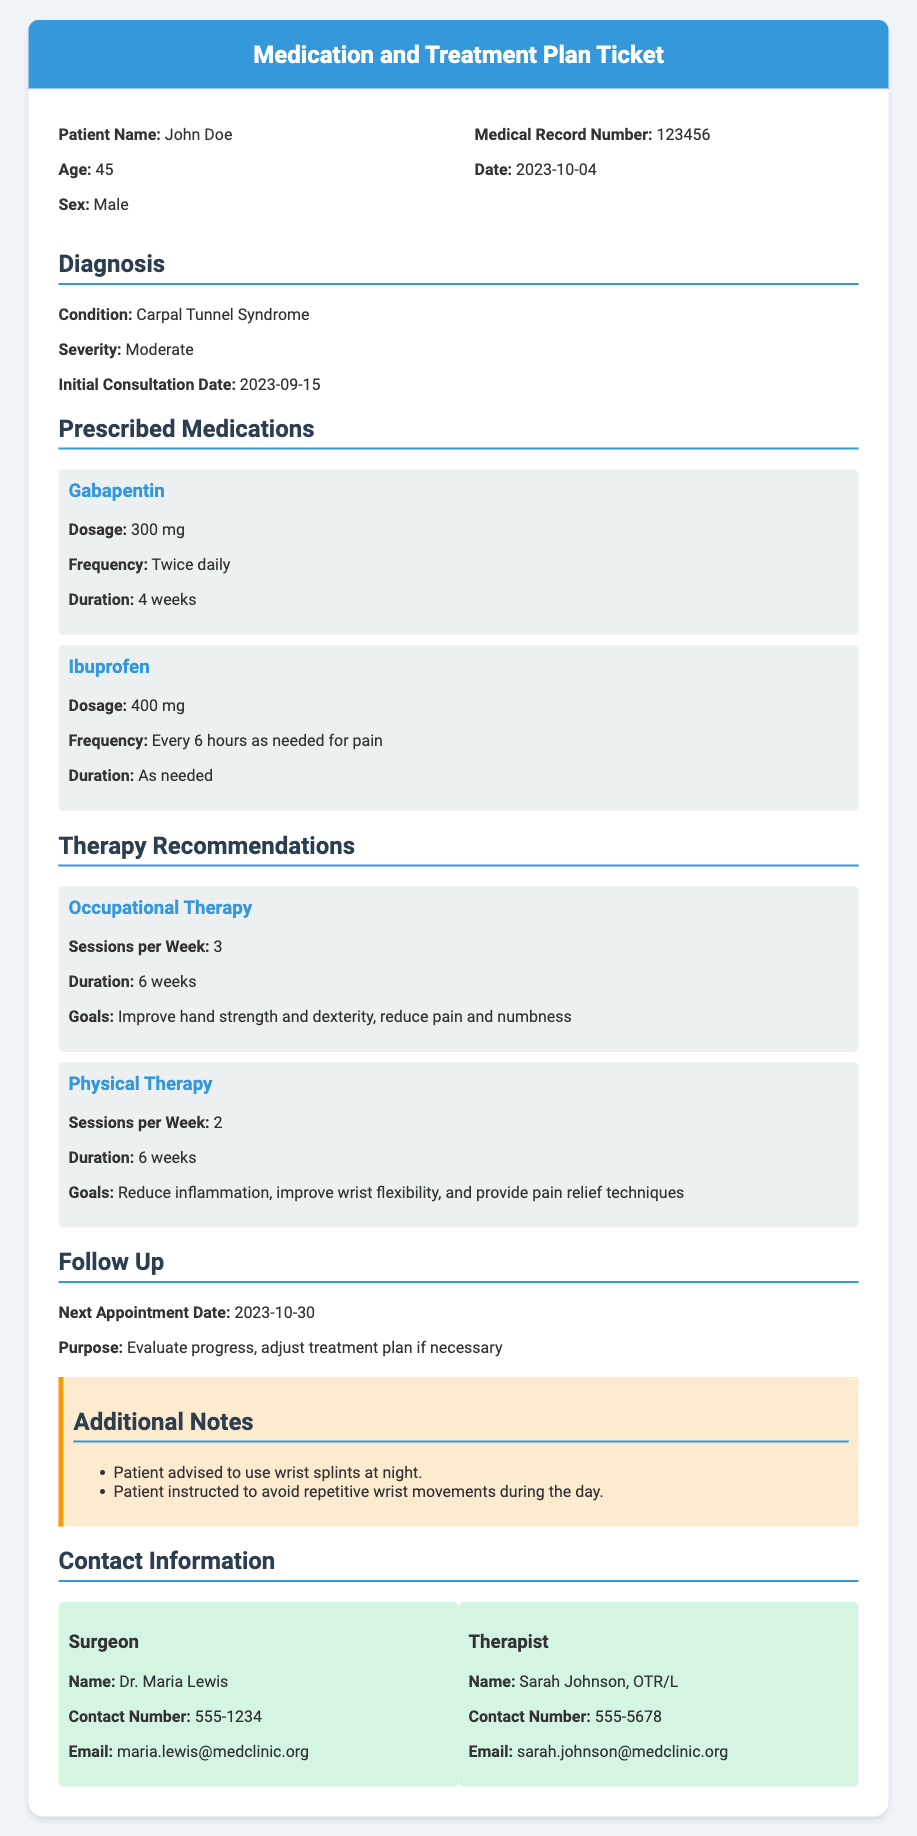What is the patient's name? The patient's name is listed in the document under the patient info section.
Answer: John Doe What is the prescribed dosage of Gabapentin? The dosage for Gabapentin is detailed in the medication section of the document.
Answer: 300 mg How many sessions of Occupational Therapy are recommended per week? The recommended sessions per week for Occupational Therapy are stated in the therapy recommendations section.
Answer: 3 What is the next appointment date? The next appointment date is provided in the follow-up section of the document.
Answer: 2023-10-30 What condition is the patient diagnosed with? The diagnosed condition is specified in the diagnosis section of the document.
Answer: Carpal Tunnel Syndrome How long is the duration for Physical Therapy? The duration for Physical Therapy is included in the therapy recommendations section.
Answer: 6 weeks What is the severity of the patient's condition? The severity of the condition is mentioned in the diagnosis section.
Answer: Moderate Who is the contact person for the therapist? The therapist's contact information is provided in the contact information section of the document.
Answer: Sarah Johnson, OTR/L What is the purpose of the next appointment? The purpose of the next appointment is stated in the follow-up section of the document.
Answer: Evaluate progress, adjust treatment plan if necessary 